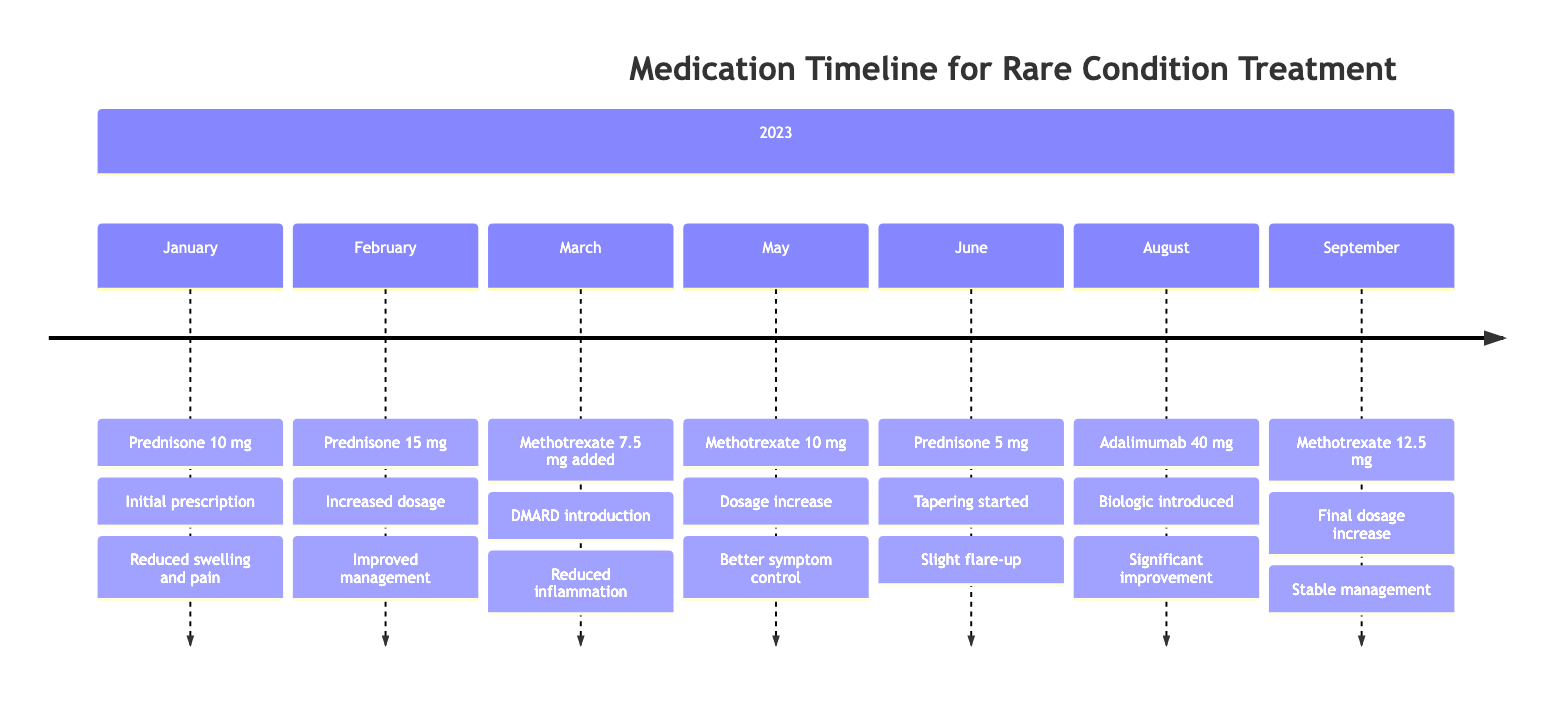What medication was added on March 20, 2023? The timeline shows that on March 20, 2023, Methotrexate was introduced as the new medication.
Answer: Methotrexate What was the dosage of Prednisone on February 10, 2023? The diagram states that on February 10, 2023, the dosage of Prednisone was increased to 15 mg.
Answer: 15 mg How many medication changes occurred in 2023? By counting the entries in the timeline, there are a total of 7 different medication changes listed for the year.
Answer: 7 What was the observed effect of the medication change on June 25, 2023? The timeline indicates that on June 25, 2023, there was a slight flare-up in symptoms as an observed effect after tapering Prednisone.
Answer: Slight flare-up What reason was given for increasing the Methotrexate dosage on May 5, 2023? According to the timeline, the reason for increasing Methotrexate dosage on May 5, 2023, was to achieve better disease control.
Answer: Better disease control On which date was Adalimumab introduced? The diagram clearly shows that Adalimumab was introduced on August 15, 2023.
Answer: August 15, 2023 What was the observed effect after starting Adalimumab? The timeline details that after starting Adalimumab, there was significant improvement in inflammation and pain.
Answer: Significant improvement What is the maximum dosage of Methotrexate mentioned in the timeline? The highest dosage of Methotrexate recorded in the timeline is 12.5 mg, indicated on September 30, 2023.
Answer: 12.5 mg 